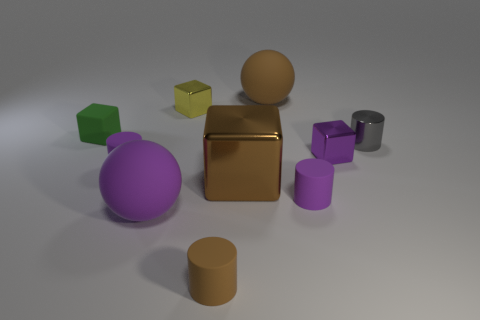How many things are either gray rubber things or cylinders to the right of the purple metallic cube?
Your answer should be compact. 1. Does the purple object that is left of the big purple matte sphere have the same material as the green block?
Make the answer very short. Yes. What is the color of the other sphere that is the same size as the brown rubber ball?
Your answer should be compact. Purple. Are there any large gray objects that have the same shape as the small yellow thing?
Provide a succinct answer. No. What is the color of the rubber sphere that is in front of the big rubber sphere behind the tiny metallic cube that is behind the gray metallic thing?
Your answer should be compact. Purple. What number of rubber objects are either purple balls or small purple cylinders?
Ensure brevity in your answer.  3. Are there more big spheres that are on the right side of the small brown object than small yellow cubes in front of the green cube?
Provide a succinct answer. Yes. How many other objects are there of the same size as the brown rubber ball?
Offer a very short reply. 2. There is a brown matte object that is behind the big matte object that is in front of the tiny green cube; what is its size?
Your answer should be compact. Large. How many big things are metallic cylinders or purple metal things?
Offer a terse response. 0. 